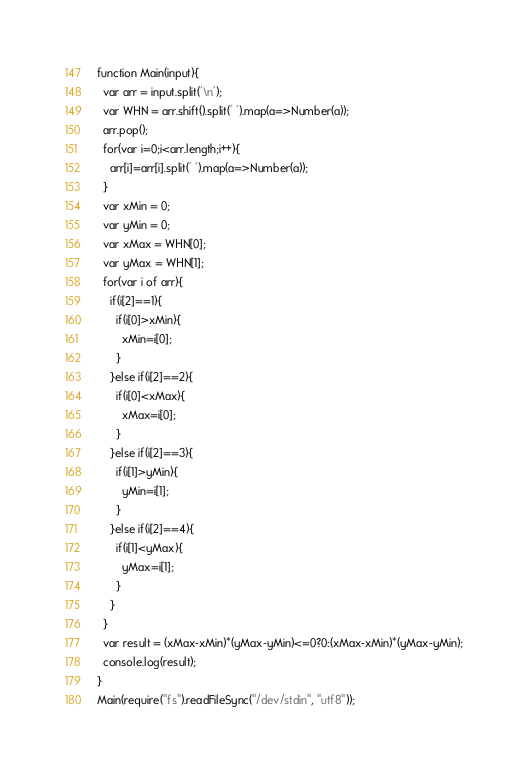<code> <loc_0><loc_0><loc_500><loc_500><_JavaScript_>function Main(input){
  var arr = input.split('\n');
  var WHN = arr.shift().split(' ').map(a=>Number(a));
  arr.pop();
  for(var i=0;i<arr.length;i++){
    arr[i]=arr[i].split(' ').map(a=>Number(a));
  }
  var xMin = 0;
  var yMin = 0;
  var xMax = WHN[0];
  var yMax = WHN[1];
  for(var i of arr){
    if(i[2]==1){
      if(i[0]>xMin){
        xMin=i[0];
      }
    }else if(i[2]==2){
      if(i[0]<xMax){
        xMax=i[0];
      }
    }else if(i[2]==3){
      if(i[1]>yMin){
        yMin=i[1];
      }
    }else if(i[2]==4){
      if(i[1]<yMax){
        yMax=i[1];
      }
    }
  }
  var result = (xMax-xMin)*(yMax-yMin)<=0?0:(xMax-xMin)*(yMax-yMin);
  console.log(result);
}
Main(require("fs").readFileSync("/dev/stdin", "utf8"));</code> 